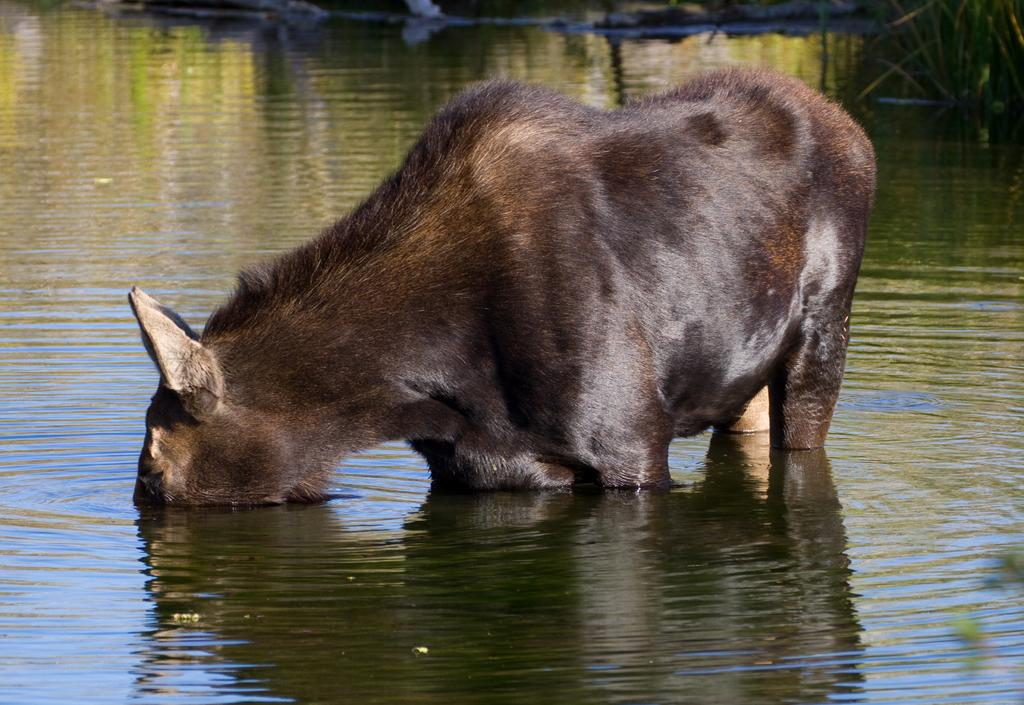What type of animal is in the image? There is an animal in the image, but its specific type cannot be determined from the provided facts. Where is the animal located in the image? The animal is in water. What is the animal doing in the image? The animal is drinking. What color is the animal in the image? The animal is black in color. Is the animal's owner present in the image? There is no mention of an owner in the provided facts, so it cannot be determined if the animal's owner is present in the image. 